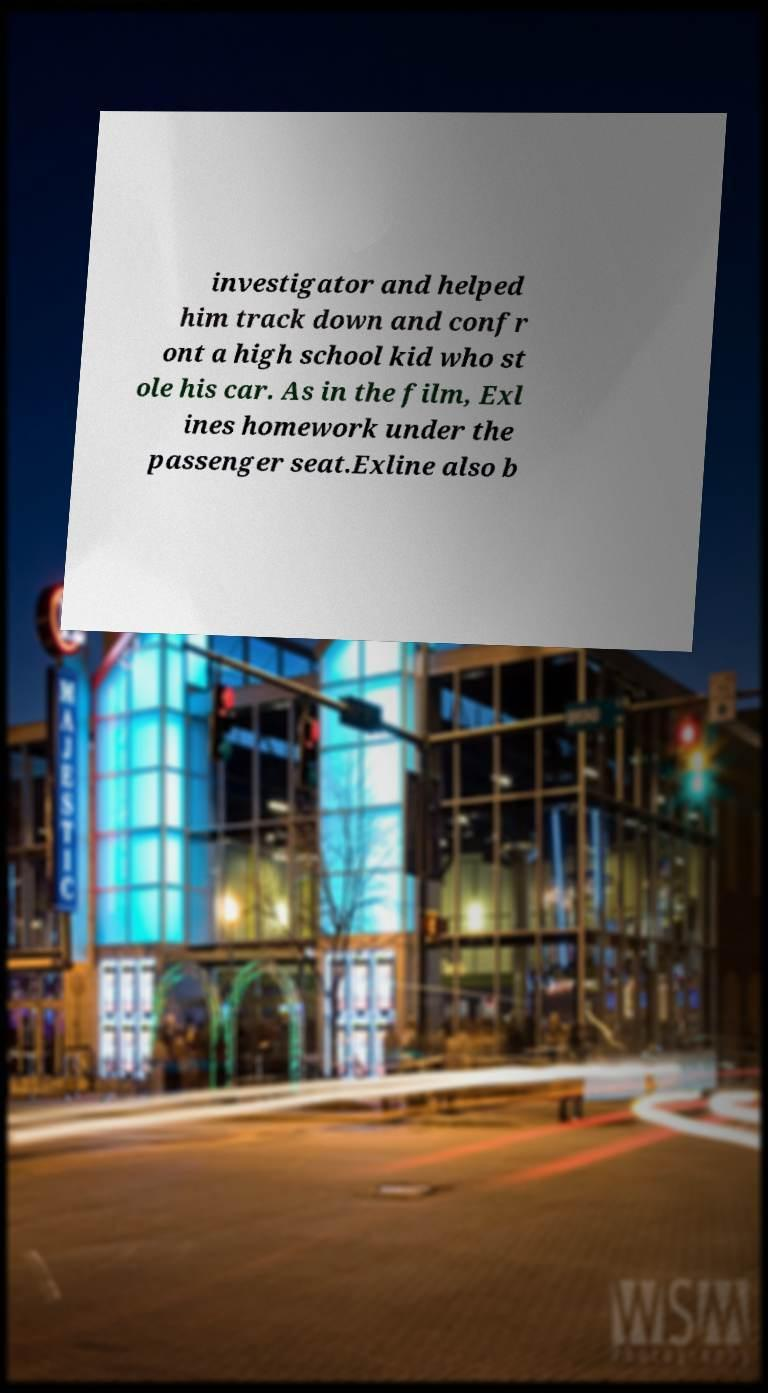Can you read and provide the text displayed in the image?This photo seems to have some interesting text. Can you extract and type it out for me? investigator and helped him track down and confr ont a high school kid who st ole his car. As in the film, Exl ines homework under the passenger seat.Exline also b 